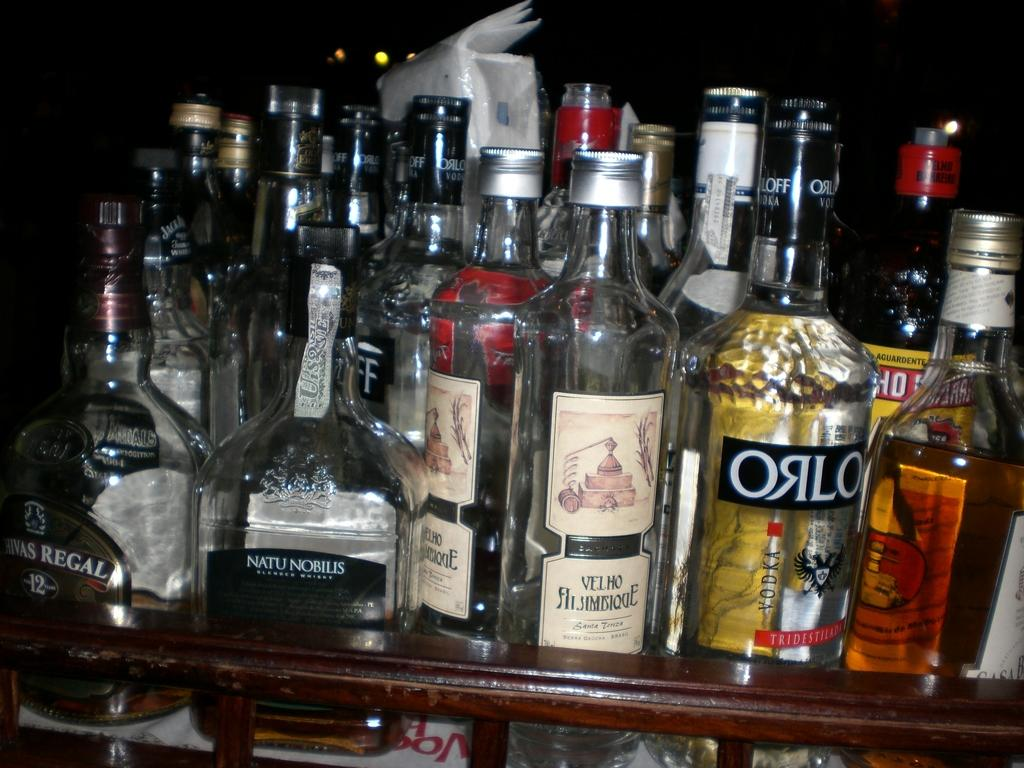<image>
Describe the image concisely. A bottle of Orlo sits among many other bottles. 